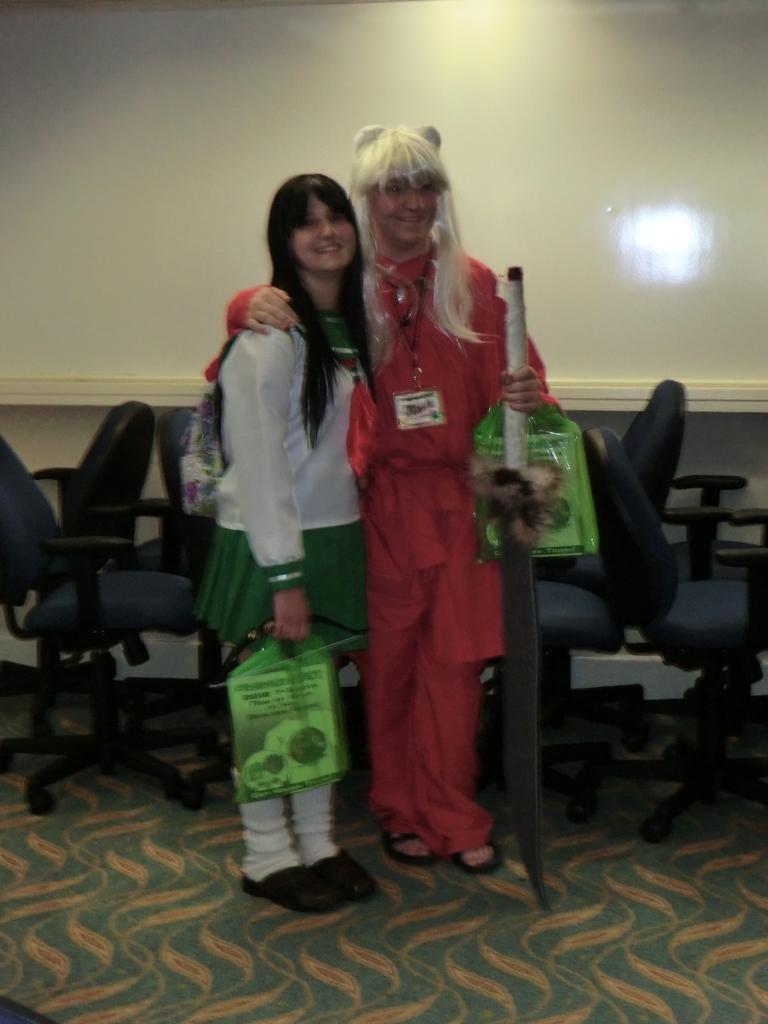How would you summarize this image in a sentence or two? In this picture we can see two persons, they both are smiling, and she wore a bag, behind to them we can see few chairs and wall. 